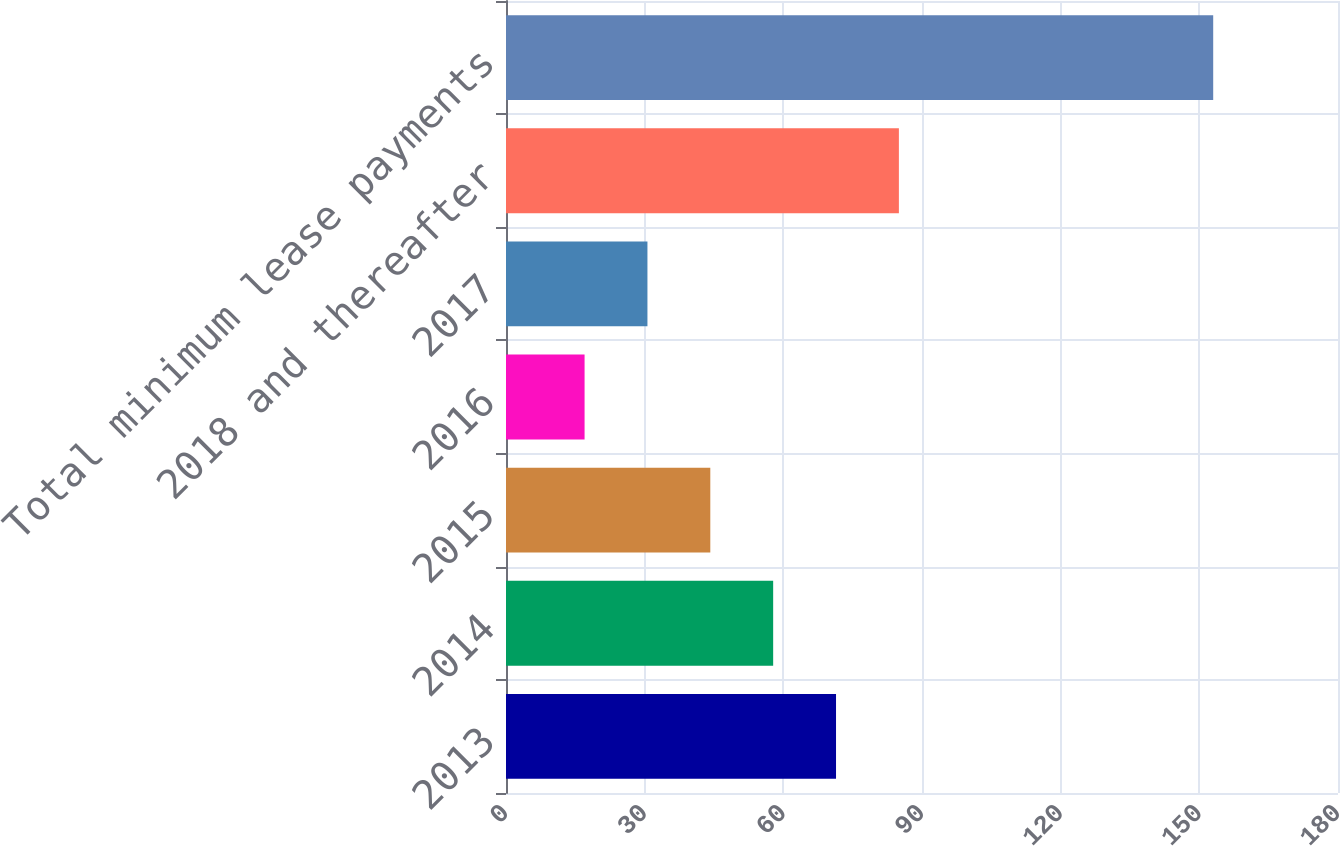<chart> <loc_0><loc_0><loc_500><loc_500><bar_chart><fcel>2013<fcel>2014<fcel>2015<fcel>2016<fcel>2017<fcel>2018 and thereafter<fcel>Total minimum lease payments<nl><fcel>71.4<fcel>57.8<fcel>44.2<fcel>17<fcel>30.6<fcel>85<fcel>153<nl></chart> 